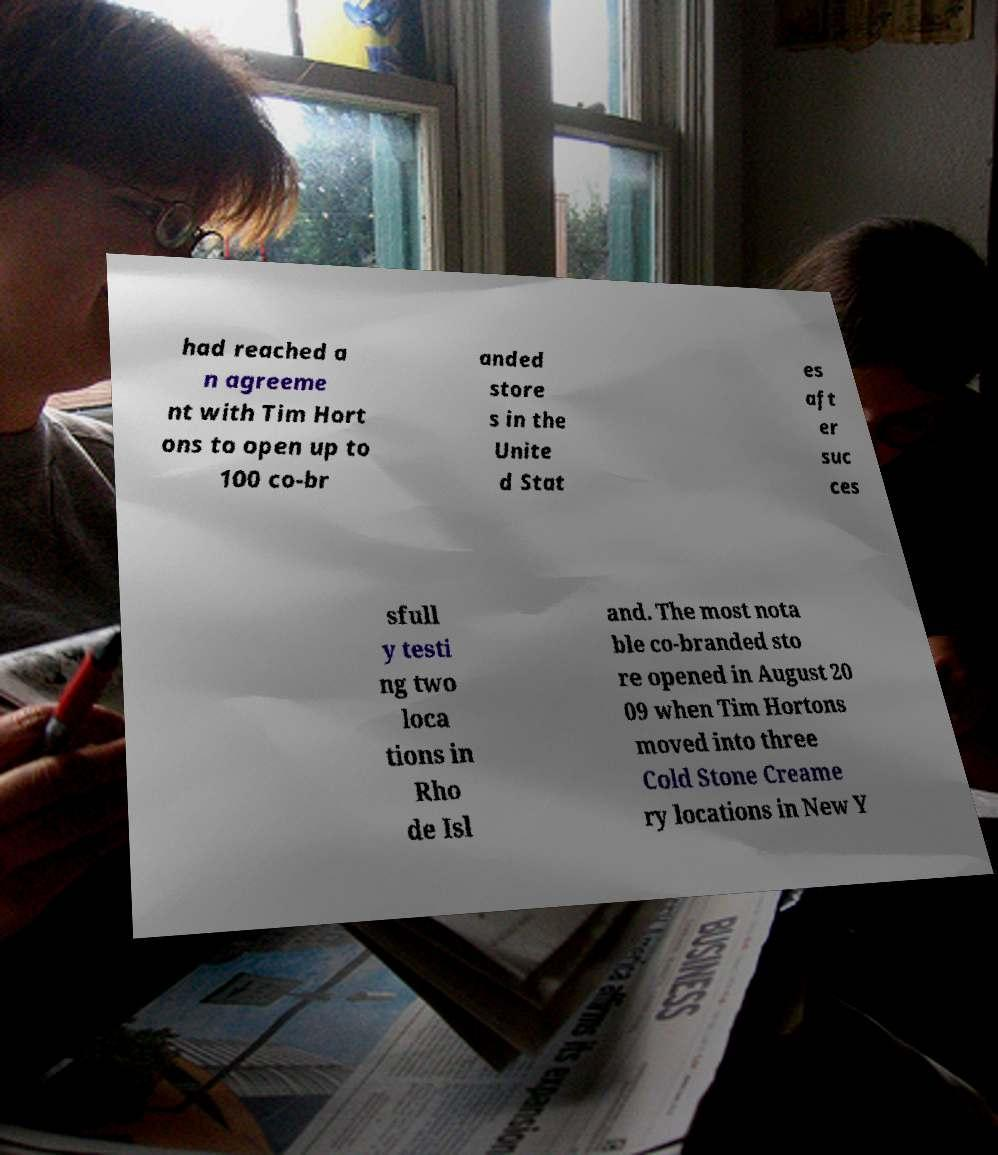Could you assist in decoding the text presented in this image and type it out clearly? had reached a n agreeme nt with Tim Hort ons to open up to 100 co-br anded store s in the Unite d Stat es aft er suc ces sfull y testi ng two loca tions in Rho de Isl and. The most nota ble co-branded sto re opened in August 20 09 when Tim Hortons moved into three Cold Stone Creame ry locations in New Y 